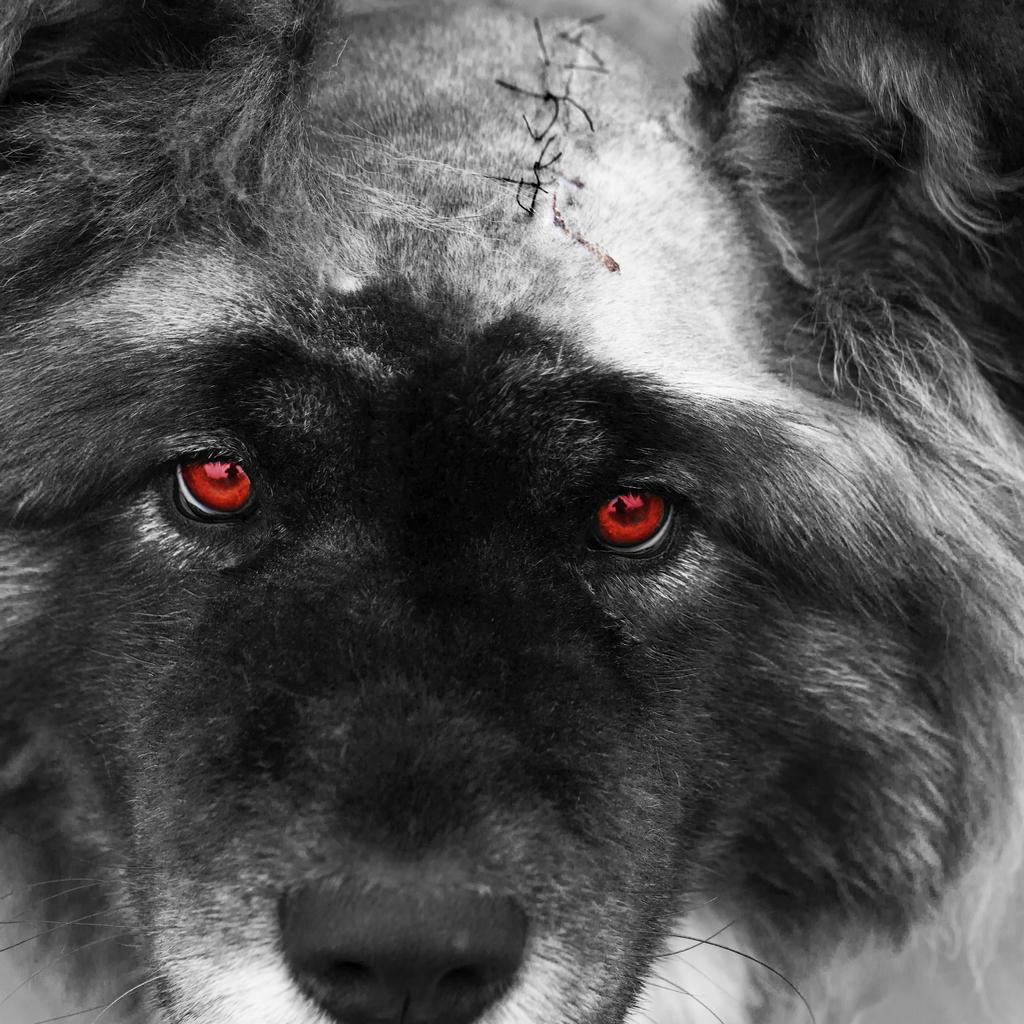What type of creature is in the picture? There is an animal in the picture. Can you describe the appearance of the animal? The animal looks like a wolf. How many girls are holding a loaf of bread in the picture? There are no girls or loaf of bread present in the image; it features an animal that looks like a wolf. What type of cable is connected to the wolf's tail in the picture? There is no cable connected to the wolf's tail in the picture; it is a standalone image of an animal that looks like a wolf. 